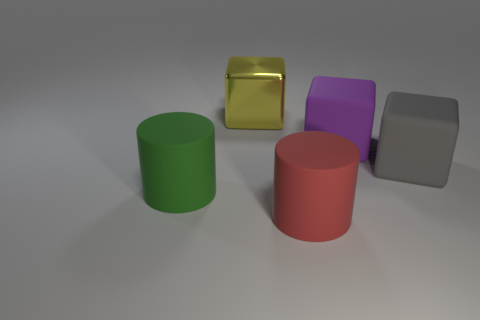Subtract all large purple cubes. How many cubes are left? 2 Add 4 blue metallic cylinders. How many objects exist? 9 Subtract all blocks. How many objects are left? 2 Subtract all purple cubes. How many cubes are left? 2 Subtract 1 cylinders. How many cylinders are left? 1 Subtract all large brown matte cubes. Subtract all big yellow metallic objects. How many objects are left? 4 Add 5 red rubber objects. How many red rubber objects are left? 6 Add 1 large red rubber things. How many large red rubber things exist? 2 Subtract 1 gray blocks. How many objects are left? 4 Subtract all purple cubes. Subtract all yellow cylinders. How many cubes are left? 2 